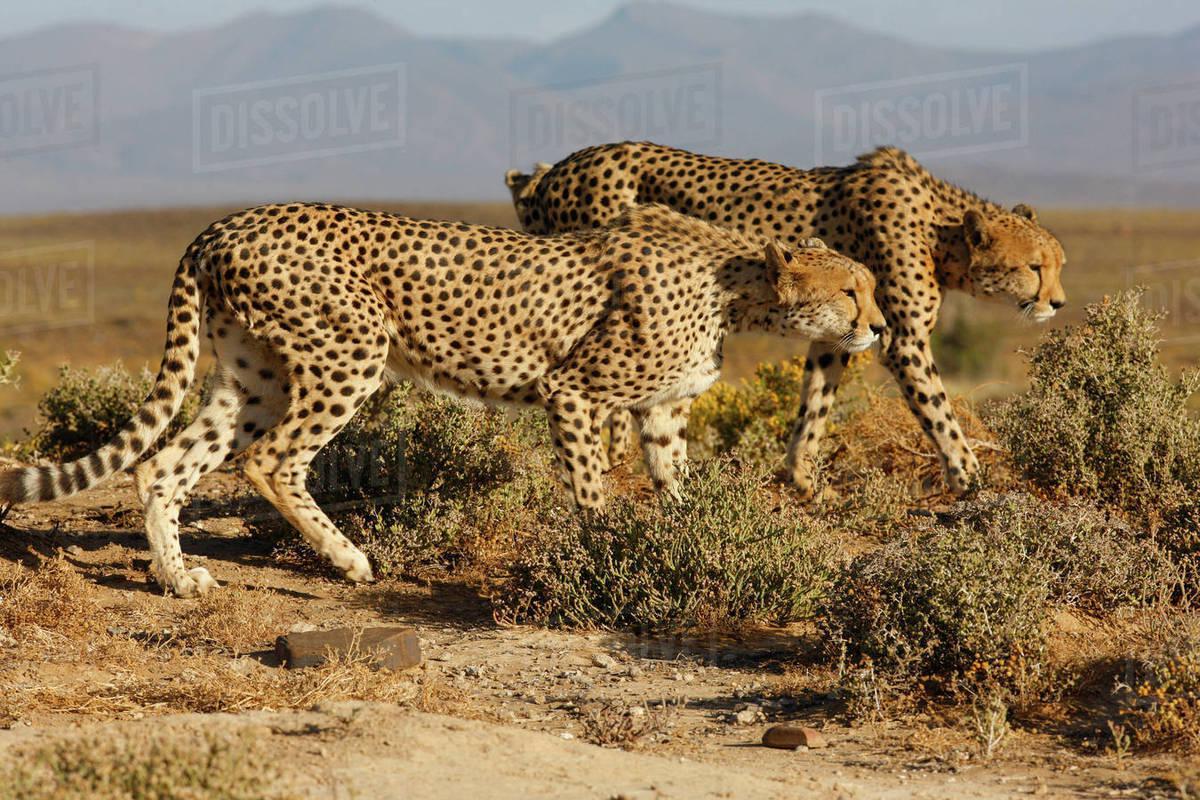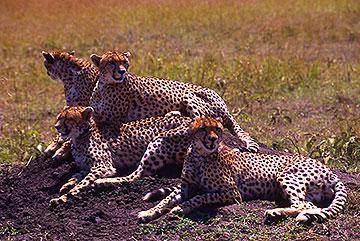The first image is the image on the left, the second image is the image on the right. Considering the images on both sides, is "One or more cheetahs are catching another animal in one of the photos." valid? Answer yes or no. No. The first image is the image on the left, the second image is the image on the right. For the images shown, is this caption "An image shows a spotted wild cat taking down its hooved prey." true? Answer yes or no. No. 